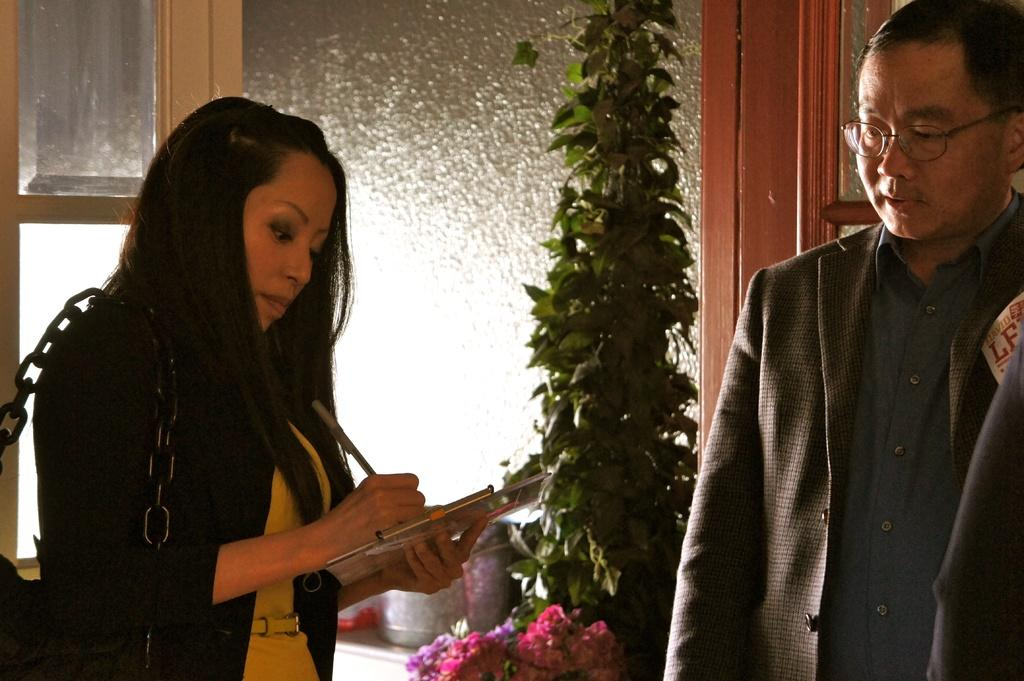How many people are present in the image? There are two people standing in the image. What is the woman wearing that is visible in the image? The woman is wearing a bag. What is the woman holding in the image? The woman is holding a pen and a book. What can be seen in the background of the image? There are green leaves and glass windows visible in the background. How many toes can be seen on the woman's feet in the image? The image does not show the woman's feet, so the number of toes cannot be determined. 